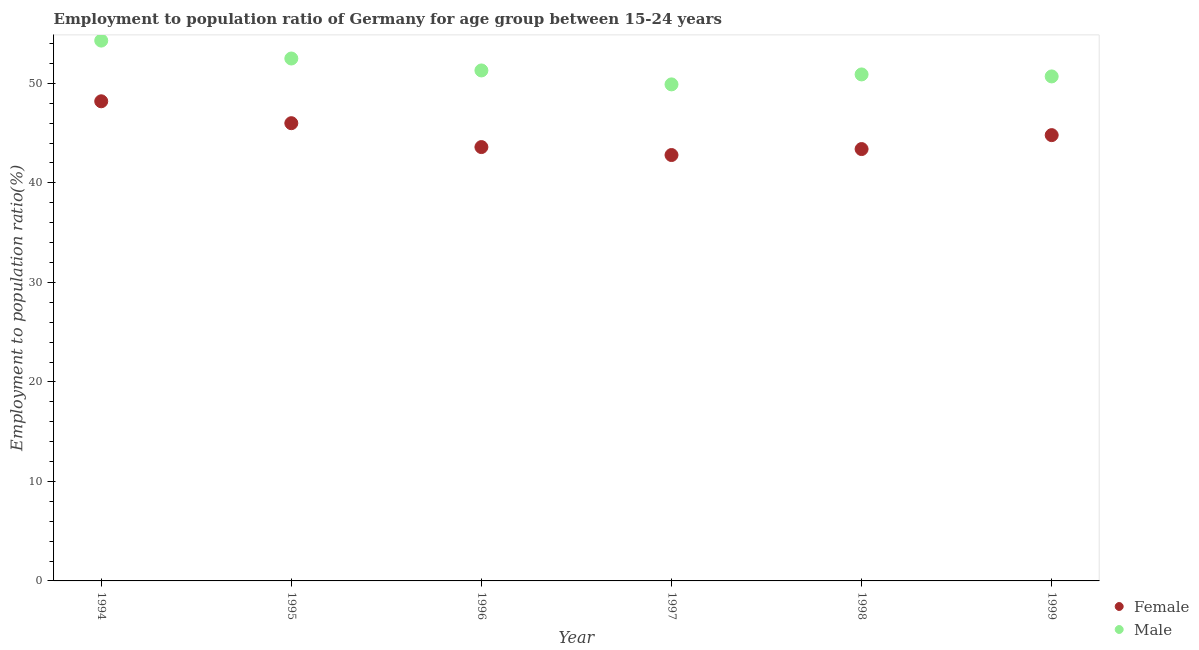How many different coloured dotlines are there?
Offer a very short reply. 2. What is the employment to population ratio(female) in 1998?
Offer a very short reply. 43.4. Across all years, what is the maximum employment to population ratio(female)?
Give a very brief answer. 48.2. Across all years, what is the minimum employment to population ratio(female)?
Offer a very short reply. 42.8. In which year was the employment to population ratio(female) minimum?
Make the answer very short. 1997. What is the total employment to population ratio(male) in the graph?
Offer a terse response. 309.6. What is the difference between the employment to population ratio(male) in 1995 and that in 1997?
Your answer should be compact. 2.6. What is the difference between the employment to population ratio(female) in 1994 and the employment to population ratio(male) in 1998?
Offer a terse response. -2.7. What is the average employment to population ratio(female) per year?
Your answer should be compact. 44.8. In the year 1994, what is the difference between the employment to population ratio(male) and employment to population ratio(female)?
Keep it short and to the point. 6.1. What is the ratio of the employment to population ratio(male) in 1995 to that in 1998?
Ensure brevity in your answer.  1.03. What is the difference between the highest and the second highest employment to population ratio(male)?
Offer a very short reply. 1.8. What is the difference between the highest and the lowest employment to population ratio(male)?
Keep it short and to the point. 4.4. In how many years, is the employment to population ratio(male) greater than the average employment to population ratio(male) taken over all years?
Provide a short and direct response. 2. How many dotlines are there?
Make the answer very short. 2. Are the values on the major ticks of Y-axis written in scientific E-notation?
Offer a terse response. No. Does the graph contain any zero values?
Give a very brief answer. No. Does the graph contain grids?
Provide a succinct answer. No. How are the legend labels stacked?
Make the answer very short. Vertical. What is the title of the graph?
Provide a short and direct response. Employment to population ratio of Germany for age group between 15-24 years. Does "Technicians" appear as one of the legend labels in the graph?
Keep it short and to the point. No. What is the label or title of the X-axis?
Offer a very short reply. Year. What is the label or title of the Y-axis?
Provide a succinct answer. Employment to population ratio(%). What is the Employment to population ratio(%) in Female in 1994?
Offer a very short reply. 48.2. What is the Employment to population ratio(%) of Male in 1994?
Keep it short and to the point. 54.3. What is the Employment to population ratio(%) in Female in 1995?
Your answer should be compact. 46. What is the Employment to population ratio(%) in Male in 1995?
Make the answer very short. 52.5. What is the Employment to population ratio(%) in Female in 1996?
Your answer should be compact. 43.6. What is the Employment to population ratio(%) in Male in 1996?
Your answer should be very brief. 51.3. What is the Employment to population ratio(%) of Female in 1997?
Keep it short and to the point. 42.8. What is the Employment to population ratio(%) in Male in 1997?
Your answer should be compact. 49.9. What is the Employment to population ratio(%) in Female in 1998?
Provide a succinct answer. 43.4. What is the Employment to population ratio(%) of Male in 1998?
Your answer should be very brief. 50.9. What is the Employment to population ratio(%) of Female in 1999?
Offer a terse response. 44.8. What is the Employment to population ratio(%) in Male in 1999?
Give a very brief answer. 50.7. Across all years, what is the maximum Employment to population ratio(%) of Female?
Keep it short and to the point. 48.2. Across all years, what is the maximum Employment to population ratio(%) of Male?
Provide a short and direct response. 54.3. Across all years, what is the minimum Employment to population ratio(%) of Female?
Offer a very short reply. 42.8. Across all years, what is the minimum Employment to population ratio(%) of Male?
Your answer should be very brief. 49.9. What is the total Employment to population ratio(%) in Female in the graph?
Provide a succinct answer. 268.8. What is the total Employment to population ratio(%) of Male in the graph?
Your response must be concise. 309.6. What is the difference between the Employment to population ratio(%) of Female in 1994 and that in 1995?
Your answer should be very brief. 2.2. What is the difference between the Employment to population ratio(%) in Male in 1994 and that in 1995?
Keep it short and to the point. 1.8. What is the difference between the Employment to population ratio(%) of Female in 1994 and that in 1996?
Offer a very short reply. 4.6. What is the difference between the Employment to population ratio(%) of Male in 1994 and that in 1996?
Offer a very short reply. 3. What is the difference between the Employment to population ratio(%) of Female in 1994 and that in 1997?
Your response must be concise. 5.4. What is the difference between the Employment to population ratio(%) in Male in 1994 and that in 1997?
Your answer should be very brief. 4.4. What is the difference between the Employment to population ratio(%) of Female in 1994 and that in 1998?
Offer a terse response. 4.8. What is the difference between the Employment to population ratio(%) of Male in 1994 and that in 1999?
Make the answer very short. 3.6. What is the difference between the Employment to population ratio(%) of Female in 1995 and that in 1996?
Provide a short and direct response. 2.4. What is the difference between the Employment to population ratio(%) of Male in 1995 and that in 1996?
Your answer should be compact. 1.2. What is the difference between the Employment to population ratio(%) in Female in 1995 and that in 1997?
Your answer should be compact. 3.2. What is the difference between the Employment to population ratio(%) in Male in 1995 and that in 1998?
Make the answer very short. 1.6. What is the difference between the Employment to population ratio(%) in Female in 1995 and that in 1999?
Provide a short and direct response. 1.2. What is the difference between the Employment to population ratio(%) of Female in 1996 and that in 1998?
Your answer should be very brief. 0.2. What is the difference between the Employment to population ratio(%) in Female in 1996 and that in 1999?
Your response must be concise. -1.2. What is the difference between the Employment to population ratio(%) of Female in 1998 and that in 1999?
Your answer should be very brief. -1.4. What is the difference between the Employment to population ratio(%) of Male in 1998 and that in 1999?
Provide a succinct answer. 0.2. What is the difference between the Employment to population ratio(%) of Female in 1994 and the Employment to population ratio(%) of Male in 1995?
Your answer should be compact. -4.3. What is the difference between the Employment to population ratio(%) of Female in 1994 and the Employment to population ratio(%) of Male in 1996?
Ensure brevity in your answer.  -3.1. What is the difference between the Employment to population ratio(%) in Female in 1995 and the Employment to population ratio(%) in Male in 1996?
Your answer should be compact. -5.3. What is the difference between the Employment to population ratio(%) of Female in 1995 and the Employment to population ratio(%) of Male in 1998?
Offer a terse response. -4.9. What is the difference between the Employment to population ratio(%) in Female in 1995 and the Employment to population ratio(%) in Male in 1999?
Your answer should be compact. -4.7. What is the difference between the Employment to population ratio(%) in Female in 1996 and the Employment to population ratio(%) in Male in 1998?
Your answer should be compact. -7.3. What is the difference between the Employment to population ratio(%) of Female in 1996 and the Employment to population ratio(%) of Male in 1999?
Keep it short and to the point. -7.1. What is the difference between the Employment to population ratio(%) of Female in 1997 and the Employment to population ratio(%) of Male in 1998?
Ensure brevity in your answer.  -8.1. What is the difference between the Employment to population ratio(%) in Female in 1997 and the Employment to population ratio(%) in Male in 1999?
Make the answer very short. -7.9. What is the average Employment to population ratio(%) of Female per year?
Keep it short and to the point. 44.8. What is the average Employment to population ratio(%) in Male per year?
Ensure brevity in your answer.  51.6. In the year 1995, what is the difference between the Employment to population ratio(%) of Female and Employment to population ratio(%) of Male?
Keep it short and to the point. -6.5. In the year 1997, what is the difference between the Employment to population ratio(%) in Female and Employment to population ratio(%) in Male?
Ensure brevity in your answer.  -7.1. What is the ratio of the Employment to population ratio(%) in Female in 1994 to that in 1995?
Offer a terse response. 1.05. What is the ratio of the Employment to population ratio(%) of Male in 1994 to that in 1995?
Your answer should be compact. 1.03. What is the ratio of the Employment to population ratio(%) in Female in 1994 to that in 1996?
Offer a terse response. 1.11. What is the ratio of the Employment to population ratio(%) of Male in 1994 to that in 1996?
Offer a terse response. 1.06. What is the ratio of the Employment to population ratio(%) of Female in 1994 to that in 1997?
Your answer should be very brief. 1.13. What is the ratio of the Employment to population ratio(%) of Male in 1994 to that in 1997?
Your answer should be very brief. 1.09. What is the ratio of the Employment to population ratio(%) in Female in 1994 to that in 1998?
Provide a short and direct response. 1.11. What is the ratio of the Employment to population ratio(%) in Male in 1994 to that in 1998?
Keep it short and to the point. 1.07. What is the ratio of the Employment to population ratio(%) of Female in 1994 to that in 1999?
Make the answer very short. 1.08. What is the ratio of the Employment to population ratio(%) of Male in 1994 to that in 1999?
Ensure brevity in your answer.  1.07. What is the ratio of the Employment to population ratio(%) in Female in 1995 to that in 1996?
Provide a succinct answer. 1.05. What is the ratio of the Employment to population ratio(%) of Male in 1995 to that in 1996?
Your answer should be very brief. 1.02. What is the ratio of the Employment to population ratio(%) of Female in 1995 to that in 1997?
Give a very brief answer. 1.07. What is the ratio of the Employment to population ratio(%) in Male in 1995 to that in 1997?
Your answer should be very brief. 1.05. What is the ratio of the Employment to population ratio(%) in Female in 1995 to that in 1998?
Ensure brevity in your answer.  1.06. What is the ratio of the Employment to population ratio(%) in Male in 1995 to that in 1998?
Provide a short and direct response. 1.03. What is the ratio of the Employment to population ratio(%) of Female in 1995 to that in 1999?
Your response must be concise. 1.03. What is the ratio of the Employment to population ratio(%) in Male in 1995 to that in 1999?
Ensure brevity in your answer.  1.04. What is the ratio of the Employment to population ratio(%) of Female in 1996 to that in 1997?
Offer a terse response. 1.02. What is the ratio of the Employment to population ratio(%) of Male in 1996 to that in 1997?
Offer a terse response. 1.03. What is the ratio of the Employment to population ratio(%) in Male in 1996 to that in 1998?
Offer a very short reply. 1.01. What is the ratio of the Employment to population ratio(%) in Female in 1996 to that in 1999?
Your answer should be compact. 0.97. What is the ratio of the Employment to population ratio(%) in Male in 1996 to that in 1999?
Your response must be concise. 1.01. What is the ratio of the Employment to population ratio(%) of Female in 1997 to that in 1998?
Offer a very short reply. 0.99. What is the ratio of the Employment to population ratio(%) in Male in 1997 to that in 1998?
Give a very brief answer. 0.98. What is the ratio of the Employment to population ratio(%) in Female in 1997 to that in 1999?
Give a very brief answer. 0.96. What is the ratio of the Employment to population ratio(%) of Male in 1997 to that in 1999?
Offer a very short reply. 0.98. What is the ratio of the Employment to population ratio(%) of Female in 1998 to that in 1999?
Keep it short and to the point. 0.97. What is the ratio of the Employment to population ratio(%) of Male in 1998 to that in 1999?
Give a very brief answer. 1. What is the difference between the highest and the second highest Employment to population ratio(%) of Male?
Your answer should be very brief. 1.8. What is the difference between the highest and the lowest Employment to population ratio(%) of Male?
Offer a terse response. 4.4. 